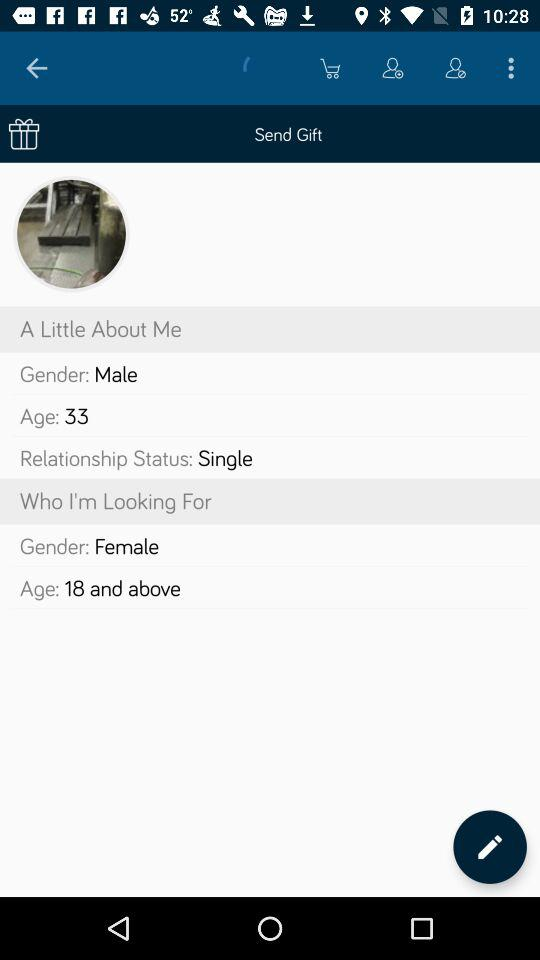What is the gender? The gender is male. 